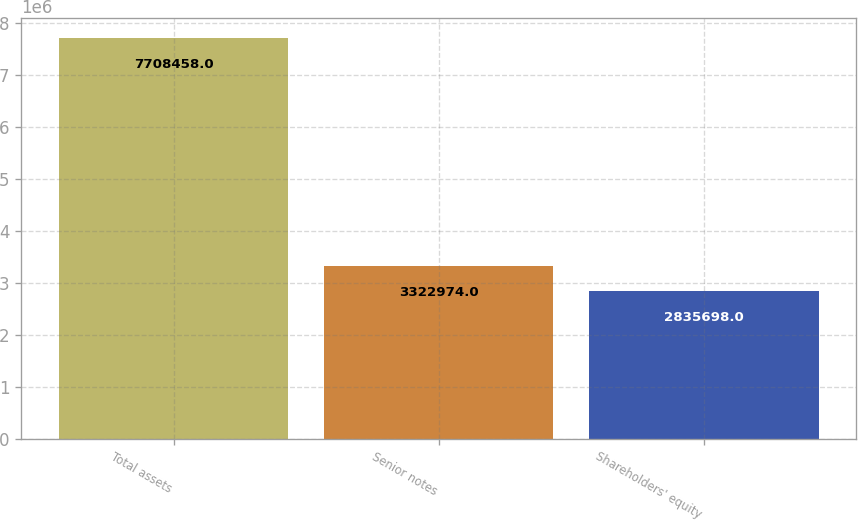Convert chart to OTSL. <chart><loc_0><loc_0><loc_500><loc_500><bar_chart><fcel>Total assets<fcel>Senior notes<fcel>Shareholders' equity<nl><fcel>7.70846e+06<fcel>3.32297e+06<fcel>2.8357e+06<nl></chart> 